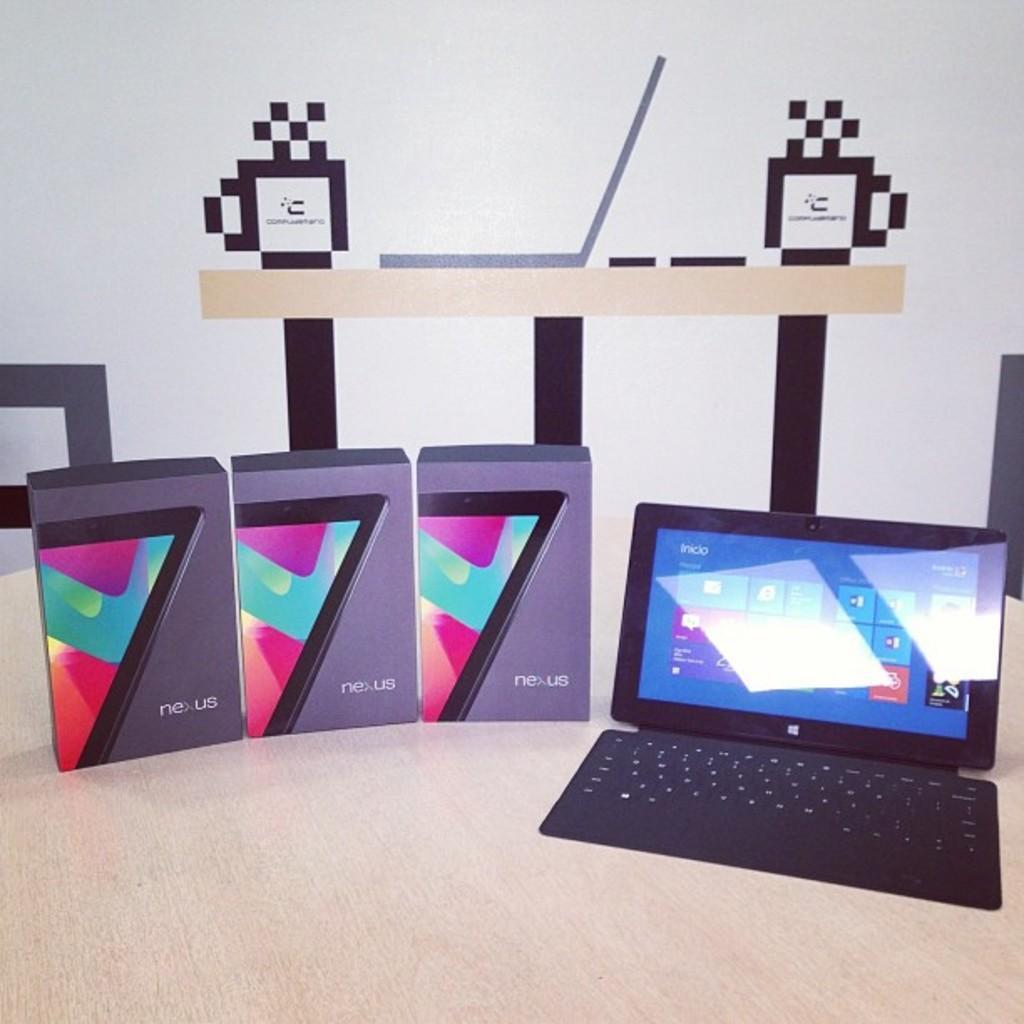How would you summarize this image in a sentence or two? In the image we can see wooden table, on it there is a laptop and three boxes. Here we can see the wall and design on the wall. 